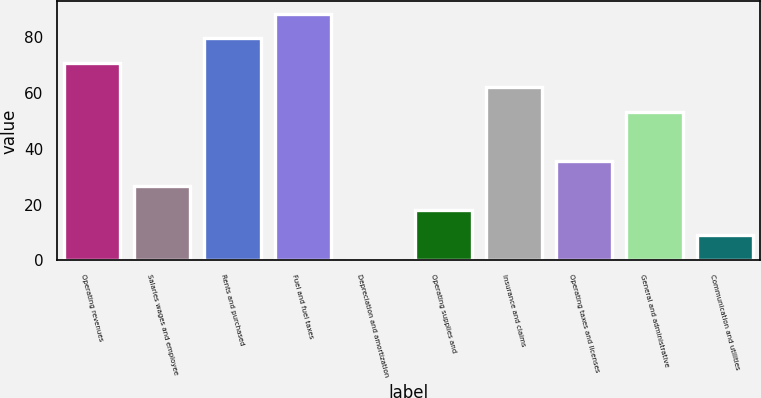<chart> <loc_0><loc_0><loc_500><loc_500><bar_chart><fcel>Operating revenues<fcel>Salaries wages and employee<fcel>Rents and purchased<fcel>Fuel and fuel taxes<fcel>Depreciation and amortization<fcel>Operating supplies and<fcel>Insurance and claims<fcel>Operating taxes and licenses<fcel>General and administrative<fcel>Communication and utilities<nl><fcel>70.78<fcel>26.73<fcel>79.59<fcel>88.4<fcel>0.3<fcel>17.92<fcel>61.97<fcel>35.54<fcel>53.16<fcel>9.11<nl></chart> 